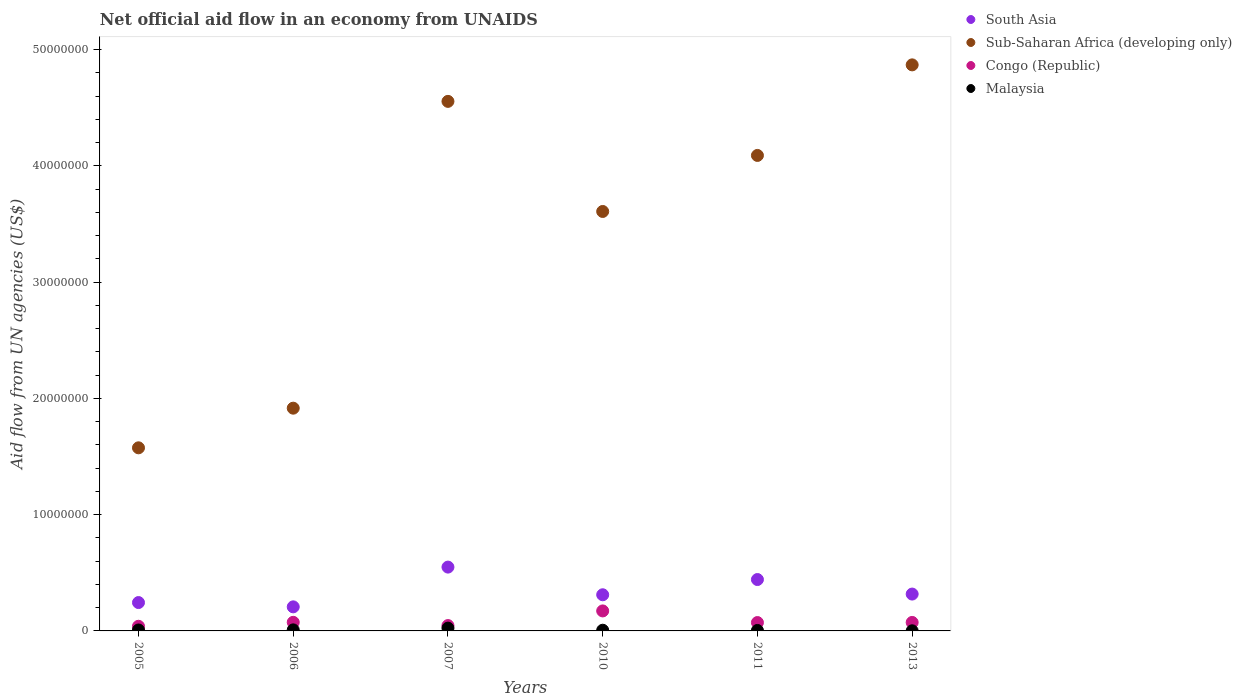How many different coloured dotlines are there?
Keep it short and to the point. 4. Is the number of dotlines equal to the number of legend labels?
Provide a short and direct response. Yes. What is the net official aid flow in Congo (Republic) in 2006?
Offer a very short reply. 7.40e+05. Across all years, what is the maximum net official aid flow in Congo (Republic)?
Give a very brief answer. 1.72e+06. Across all years, what is the minimum net official aid flow in South Asia?
Make the answer very short. 2.07e+06. In which year was the net official aid flow in Congo (Republic) maximum?
Give a very brief answer. 2010. What is the total net official aid flow in Congo (Republic) in the graph?
Offer a very short reply. 4.77e+06. What is the difference between the net official aid flow in South Asia in 2007 and that in 2013?
Your answer should be very brief. 2.32e+06. What is the difference between the net official aid flow in Malaysia in 2011 and the net official aid flow in Congo (Republic) in 2013?
Make the answer very short. -6.90e+05. What is the average net official aid flow in Congo (Republic) per year?
Give a very brief answer. 7.95e+05. In the year 2013, what is the difference between the net official aid flow in Malaysia and net official aid flow in South Asia?
Ensure brevity in your answer.  -3.16e+06. In how many years, is the net official aid flow in Malaysia greater than 2000000 US$?
Your answer should be compact. 0. What is the ratio of the net official aid flow in South Asia in 2006 to that in 2013?
Offer a terse response. 0.65. Is the net official aid flow in Malaysia in 2010 less than that in 2011?
Offer a very short reply. No. What is the difference between the highest and the second highest net official aid flow in Congo (Republic)?
Provide a succinct answer. 9.80e+05. What is the difference between the highest and the lowest net official aid flow in Congo (Republic)?
Your answer should be very brief. 1.32e+06. Is the sum of the net official aid flow in Malaysia in 2005 and 2013 greater than the maximum net official aid flow in Sub-Saharan Africa (developing only) across all years?
Offer a very short reply. No. Is it the case that in every year, the sum of the net official aid flow in Congo (Republic) and net official aid flow in South Asia  is greater than the sum of net official aid flow in Malaysia and net official aid flow in Sub-Saharan Africa (developing only)?
Your answer should be very brief. No. Is it the case that in every year, the sum of the net official aid flow in Malaysia and net official aid flow in South Asia  is greater than the net official aid flow in Sub-Saharan Africa (developing only)?
Your response must be concise. No. Does the net official aid flow in Malaysia monotonically increase over the years?
Give a very brief answer. No. How many years are there in the graph?
Ensure brevity in your answer.  6. What is the difference between two consecutive major ticks on the Y-axis?
Your answer should be very brief. 1.00e+07. Are the values on the major ticks of Y-axis written in scientific E-notation?
Offer a terse response. No. Does the graph contain any zero values?
Offer a very short reply. No. How many legend labels are there?
Your answer should be compact. 4. How are the legend labels stacked?
Offer a terse response. Vertical. What is the title of the graph?
Your answer should be very brief. Net official aid flow in an economy from UNAIDS. What is the label or title of the Y-axis?
Ensure brevity in your answer.  Aid flow from UN agencies (US$). What is the Aid flow from UN agencies (US$) in South Asia in 2005?
Offer a very short reply. 2.44e+06. What is the Aid flow from UN agencies (US$) of Sub-Saharan Africa (developing only) in 2005?
Your answer should be compact. 1.58e+07. What is the Aid flow from UN agencies (US$) of South Asia in 2006?
Your answer should be very brief. 2.07e+06. What is the Aid flow from UN agencies (US$) in Sub-Saharan Africa (developing only) in 2006?
Your response must be concise. 1.92e+07. What is the Aid flow from UN agencies (US$) of Congo (Republic) in 2006?
Ensure brevity in your answer.  7.40e+05. What is the Aid flow from UN agencies (US$) in South Asia in 2007?
Offer a very short reply. 5.49e+06. What is the Aid flow from UN agencies (US$) of Sub-Saharan Africa (developing only) in 2007?
Your answer should be compact. 4.56e+07. What is the Aid flow from UN agencies (US$) of Congo (Republic) in 2007?
Ensure brevity in your answer.  4.60e+05. What is the Aid flow from UN agencies (US$) of South Asia in 2010?
Ensure brevity in your answer.  3.11e+06. What is the Aid flow from UN agencies (US$) in Sub-Saharan Africa (developing only) in 2010?
Provide a succinct answer. 3.61e+07. What is the Aid flow from UN agencies (US$) in Congo (Republic) in 2010?
Offer a terse response. 1.72e+06. What is the Aid flow from UN agencies (US$) in South Asia in 2011?
Keep it short and to the point. 4.42e+06. What is the Aid flow from UN agencies (US$) in Sub-Saharan Africa (developing only) in 2011?
Make the answer very short. 4.09e+07. What is the Aid flow from UN agencies (US$) in Congo (Republic) in 2011?
Provide a short and direct response. 7.20e+05. What is the Aid flow from UN agencies (US$) of Malaysia in 2011?
Your answer should be very brief. 4.00e+04. What is the Aid flow from UN agencies (US$) of South Asia in 2013?
Your answer should be compact. 3.17e+06. What is the Aid flow from UN agencies (US$) of Sub-Saharan Africa (developing only) in 2013?
Your answer should be very brief. 4.87e+07. What is the Aid flow from UN agencies (US$) of Congo (Republic) in 2013?
Provide a short and direct response. 7.30e+05. Across all years, what is the maximum Aid flow from UN agencies (US$) in South Asia?
Keep it short and to the point. 5.49e+06. Across all years, what is the maximum Aid flow from UN agencies (US$) in Sub-Saharan Africa (developing only)?
Your response must be concise. 4.87e+07. Across all years, what is the maximum Aid flow from UN agencies (US$) of Congo (Republic)?
Make the answer very short. 1.72e+06. Across all years, what is the minimum Aid flow from UN agencies (US$) in South Asia?
Your answer should be very brief. 2.07e+06. Across all years, what is the minimum Aid flow from UN agencies (US$) in Sub-Saharan Africa (developing only)?
Keep it short and to the point. 1.58e+07. Across all years, what is the minimum Aid flow from UN agencies (US$) of Congo (Republic)?
Make the answer very short. 4.00e+05. Across all years, what is the minimum Aid flow from UN agencies (US$) of Malaysia?
Give a very brief answer. 10000. What is the total Aid flow from UN agencies (US$) of South Asia in the graph?
Offer a terse response. 2.07e+07. What is the total Aid flow from UN agencies (US$) in Sub-Saharan Africa (developing only) in the graph?
Keep it short and to the point. 2.06e+08. What is the total Aid flow from UN agencies (US$) of Congo (Republic) in the graph?
Give a very brief answer. 4.77e+06. What is the total Aid flow from UN agencies (US$) in Malaysia in the graph?
Make the answer very short. 5.20e+05. What is the difference between the Aid flow from UN agencies (US$) of South Asia in 2005 and that in 2006?
Make the answer very short. 3.70e+05. What is the difference between the Aid flow from UN agencies (US$) of Sub-Saharan Africa (developing only) in 2005 and that in 2006?
Provide a short and direct response. -3.41e+06. What is the difference between the Aid flow from UN agencies (US$) in Malaysia in 2005 and that in 2006?
Offer a terse response. -10000. What is the difference between the Aid flow from UN agencies (US$) of South Asia in 2005 and that in 2007?
Offer a terse response. -3.05e+06. What is the difference between the Aid flow from UN agencies (US$) in Sub-Saharan Africa (developing only) in 2005 and that in 2007?
Offer a very short reply. -2.98e+07. What is the difference between the Aid flow from UN agencies (US$) in South Asia in 2005 and that in 2010?
Keep it short and to the point. -6.70e+05. What is the difference between the Aid flow from UN agencies (US$) of Sub-Saharan Africa (developing only) in 2005 and that in 2010?
Give a very brief answer. -2.03e+07. What is the difference between the Aid flow from UN agencies (US$) in Congo (Republic) in 2005 and that in 2010?
Make the answer very short. -1.32e+06. What is the difference between the Aid flow from UN agencies (US$) in South Asia in 2005 and that in 2011?
Ensure brevity in your answer.  -1.98e+06. What is the difference between the Aid flow from UN agencies (US$) of Sub-Saharan Africa (developing only) in 2005 and that in 2011?
Provide a short and direct response. -2.52e+07. What is the difference between the Aid flow from UN agencies (US$) in Congo (Republic) in 2005 and that in 2011?
Provide a succinct answer. -3.20e+05. What is the difference between the Aid flow from UN agencies (US$) in South Asia in 2005 and that in 2013?
Make the answer very short. -7.30e+05. What is the difference between the Aid flow from UN agencies (US$) in Sub-Saharan Africa (developing only) in 2005 and that in 2013?
Your answer should be compact. -3.29e+07. What is the difference between the Aid flow from UN agencies (US$) in Congo (Republic) in 2005 and that in 2013?
Make the answer very short. -3.30e+05. What is the difference between the Aid flow from UN agencies (US$) of Malaysia in 2005 and that in 2013?
Keep it short and to the point. 7.00e+04. What is the difference between the Aid flow from UN agencies (US$) of South Asia in 2006 and that in 2007?
Provide a short and direct response. -3.42e+06. What is the difference between the Aid flow from UN agencies (US$) in Sub-Saharan Africa (developing only) in 2006 and that in 2007?
Offer a terse response. -2.64e+07. What is the difference between the Aid flow from UN agencies (US$) of Malaysia in 2006 and that in 2007?
Make the answer very short. -1.50e+05. What is the difference between the Aid flow from UN agencies (US$) of South Asia in 2006 and that in 2010?
Make the answer very short. -1.04e+06. What is the difference between the Aid flow from UN agencies (US$) of Sub-Saharan Africa (developing only) in 2006 and that in 2010?
Ensure brevity in your answer.  -1.69e+07. What is the difference between the Aid flow from UN agencies (US$) of Congo (Republic) in 2006 and that in 2010?
Ensure brevity in your answer.  -9.80e+05. What is the difference between the Aid flow from UN agencies (US$) in South Asia in 2006 and that in 2011?
Make the answer very short. -2.35e+06. What is the difference between the Aid flow from UN agencies (US$) in Sub-Saharan Africa (developing only) in 2006 and that in 2011?
Your response must be concise. -2.17e+07. What is the difference between the Aid flow from UN agencies (US$) of South Asia in 2006 and that in 2013?
Give a very brief answer. -1.10e+06. What is the difference between the Aid flow from UN agencies (US$) of Sub-Saharan Africa (developing only) in 2006 and that in 2013?
Offer a very short reply. -2.95e+07. What is the difference between the Aid flow from UN agencies (US$) in Congo (Republic) in 2006 and that in 2013?
Keep it short and to the point. 10000. What is the difference between the Aid flow from UN agencies (US$) of South Asia in 2007 and that in 2010?
Keep it short and to the point. 2.38e+06. What is the difference between the Aid flow from UN agencies (US$) of Sub-Saharan Africa (developing only) in 2007 and that in 2010?
Keep it short and to the point. 9.47e+06. What is the difference between the Aid flow from UN agencies (US$) of Congo (Republic) in 2007 and that in 2010?
Your answer should be very brief. -1.26e+06. What is the difference between the Aid flow from UN agencies (US$) of South Asia in 2007 and that in 2011?
Offer a very short reply. 1.07e+06. What is the difference between the Aid flow from UN agencies (US$) in Sub-Saharan Africa (developing only) in 2007 and that in 2011?
Make the answer very short. 4.65e+06. What is the difference between the Aid flow from UN agencies (US$) of Congo (Republic) in 2007 and that in 2011?
Provide a succinct answer. -2.60e+05. What is the difference between the Aid flow from UN agencies (US$) of Malaysia in 2007 and that in 2011?
Ensure brevity in your answer.  2.00e+05. What is the difference between the Aid flow from UN agencies (US$) in South Asia in 2007 and that in 2013?
Keep it short and to the point. 2.32e+06. What is the difference between the Aid flow from UN agencies (US$) of Sub-Saharan Africa (developing only) in 2007 and that in 2013?
Ensure brevity in your answer.  -3.14e+06. What is the difference between the Aid flow from UN agencies (US$) in South Asia in 2010 and that in 2011?
Your response must be concise. -1.31e+06. What is the difference between the Aid flow from UN agencies (US$) of Sub-Saharan Africa (developing only) in 2010 and that in 2011?
Give a very brief answer. -4.82e+06. What is the difference between the Aid flow from UN agencies (US$) of Malaysia in 2010 and that in 2011?
Your response must be concise. 2.00e+04. What is the difference between the Aid flow from UN agencies (US$) in Sub-Saharan Africa (developing only) in 2010 and that in 2013?
Your answer should be very brief. -1.26e+07. What is the difference between the Aid flow from UN agencies (US$) of Congo (Republic) in 2010 and that in 2013?
Provide a succinct answer. 9.90e+05. What is the difference between the Aid flow from UN agencies (US$) of South Asia in 2011 and that in 2013?
Your answer should be very brief. 1.25e+06. What is the difference between the Aid flow from UN agencies (US$) of Sub-Saharan Africa (developing only) in 2011 and that in 2013?
Ensure brevity in your answer.  -7.79e+06. What is the difference between the Aid flow from UN agencies (US$) in South Asia in 2005 and the Aid flow from UN agencies (US$) in Sub-Saharan Africa (developing only) in 2006?
Make the answer very short. -1.67e+07. What is the difference between the Aid flow from UN agencies (US$) in South Asia in 2005 and the Aid flow from UN agencies (US$) in Congo (Republic) in 2006?
Provide a succinct answer. 1.70e+06. What is the difference between the Aid flow from UN agencies (US$) of South Asia in 2005 and the Aid flow from UN agencies (US$) of Malaysia in 2006?
Keep it short and to the point. 2.35e+06. What is the difference between the Aid flow from UN agencies (US$) in Sub-Saharan Africa (developing only) in 2005 and the Aid flow from UN agencies (US$) in Congo (Republic) in 2006?
Ensure brevity in your answer.  1.50e+07. What is the difference between the Aid flow from UN agencies (US$) of Sub-Saharan Africa (developing only) in 2005 and the Aid flow from UN agencies (US$) of Malaysia in 2006?
Offer a very short reply. 1.57e+07. What is the difference between the Aid flow from UN agencies (US$) in Congo (Republic) in 2005 and the Aid flow from UN agencies (US$) in Malaysia in 2006?
Provide a succinct answer. 3.10e+05. What is the difference between the Aid flow from UN agencies (US$) in South Asia in 2005 and the Aid flow from UN agencies (US$) in Sub-Saharan Africa (developing only) in 2007?
Your answer should be compact. -4.31e+07. What is the difference between the Aid flow from UN agencies (US$) in South Asia in 2005 and the Aid flow from UN agencies (US$) in Congo (Republic) in 2007?
Your response must be concise. 1.98e+06. What is the difference between the Aid flow from UN agencies (US$) of South Asia in 2005 and the Aid flow from UN agencies (US$) of Malaysia in 2007?
Offer a very short reply. 2.20e+06. What is the difference between the Aid flow from UN agencies (US$) in Sub-Saharan Africa (developing only) in 2005 and the Aid flow from UN agencies (US$) in Congo (Republic) in 2007?
Your answer should be very brief. 1.53e+07. What is the difference between the Aid flow from UN agencies (US$) in Sub-Saharan Africa (developing only) in 2005 and the Aid flow from UN agencies (US$) in Malaysia in 2007?
Offer a very short reply. 1.55e+07. What is the difference between the Aid flow from UN agencies (US$) in Congo (Republic) in 2005 and the Aid flow from UN agencies (US$) in Malaysia in 2007?
Provide a short and direct response. 1.60e+05. What is the difference between the Aid flow from UN agencies (US$) of South Asia in 2005 and the Aid flow from UN agencies (US$) of Sub-Saharan Africa (developing only) in 2010?
Offer a very short reply. -3.36e+07. What is the difference between the Aid flow from UN agencies (US$) of South Asia in 2005 and the Aid flow from UN agencies (US$) of Congo (Republic) in 2010?
Keep it short and to the point. 7.20e+05. What is the difference between the Aid flow from UN agencies (US$) in South Asia in 2005 and the Aid flow from UN agencies (US$) in Malaysia in 2010?
Give a very brief answer. 2.38e+06. What is the difference between the Aid flow from UN agencies (US$) of Sub-Saharan Africa (developing only) in 2005 and the Aid flow from UN agencies (US$) of Congo (Republic) in 2010?
Keep it short and to the point. 1.40e+07. What is the difference between the Aid flow from UN agencies (US$) of Sub-Saharan Africa (developing only) in 2005 and the Aid flow from UN agencies (US$) of Malaysia in 2010?
Keep it short and to the point. 1.57e+07. What is the difference between the Aid flow from UN agencies (US$) in South Asia in 2005 and the Aid flow from UN agencies (US$) in Sub-Saharan Africa (developing only) in 2011?
Ensure brevity in your answer.  -3.85e+07. What is the difference between the Aid flow from UN agencies (US$) of South Asia in 2005 and the Aid flow from UN agencies (US$) of Congo (Republic) in 2011?
Provide a short and direct response. 1.72e+06. What is the difference between the Aid flow from UN agencies (US$) of South Asia in 2005 and the Aid flow from UN agencies (US$) of Malaysia in 2011?
Your answer should be compact. 2.40e+06. What is the difference between the Aid flow from UN agencies (US$) of Sub-Saharan Africa (developing only) in 2005 and the Aid flow from UN agencies (US$) of Congo (Republic) in 2011?
Make the answer very short. 1.50e+07. What is the difference between the Aid flow from UN agencies (US$) in Sub-Saharan Africa (developing only) in 2005 and the Aid flow from UN agencies (US$) in Malaysia in 2011?
Your answer should be compact. 1.57e+07. What is the difference between the Aid flow from UN agencies (US$) in Congo (Republic) in 2005 and the Aid flow from UN agencies (US$) in Malaysia in 2011?
Your response must be concise. 3.60e+05. What is the difference between the Aid flow from UN agencies (US$) of South Asia in 2005 and the Aid flow from UN agencies (US$) of Sub-Saharan Africa (developing only) in 2013?
Provide a succinct answer. -4.62e+07. What is the difference between the Aid flow from UN agencies (US$) of South Asia in 2005 and the Aid flow from UN agencies (US$) of Congo (Republic) in 2013?
Ensure brevity in your answer.  1.71e+06. What is the difference between the Aid flow from UN agencies (US$) of South Asia in 2005 and the Aid flow from UN agencies (US$) of Malaysia in 2013?
Offer a very short reply. 2.43e+06. What is the difference between the Aid flow from UN agencies (US$) in Sub-Saharan Africa (developing only) in 2005 and the Aid flow from UN agencies (US$) in Congo (Republic) in 2013?
Provide a short and direct response. 1.50e+07. What is the difference between the Aid flow from UN agencies (US$) of Sub-Saharan Africa (developing only) in 2005 and the Aid flow from UN agencies (US$) of Malaysia in 2013?
Offer a very short reply. 1.57e+07. What is the difference between the Aid flow from UN agencies (US$) in Congo (Republic) in 2005 and the Aid flow from UN agencies (US$) in Malaysia in 2013?
Offer a very short reply. 3.90e+05. What is the difference between the Aid flow from UN agencies (US$) in South Asia in 2006 and the Aid flow from UN agencies (US$) in Sub-Saharan Africa (developing only) in 2007?
Make the answer very short. -4.35e+07. What is the difference between the Aid flow from UN agencies (US$) of South Asia in 2006 and the Aid flow from UN agencies (US$) of Congo (Republic) in 2007?
Give a very brief answer. 1.61e+06. What is the difference between the Aid flow from UN agencies (US$) of South Asia in 2006 and the Aid flow from UN agencies (US$) of Malaysia in 2007?
Give a very brief answer. 1.83e+06. What is the difference between the Aid flow from UN agencies (US$) in Sub-Saharan Africa (developing only) in 2006 and the Aid flow from UN agencies (US$) in Congo (Republic) in 2007?
Provide a succinct answer. 1.87e+07. What is the difference between the Aid flow from UN agencies (US$) in Sub-Saharan Africa (developing only) in 2006 and the Aid flow from UN agencies (US$) in Malaysia in 2007?
Offer a very short reply. 1.89e+07. What is the difference between the Aid flow from UN agencies (US$) in South Asia in 2006 and the Aid flow from UN agencies (US$) in Sub-Saharan Africa (developing only) in 2010?
Provide a short and direct response. -3.40e+07. What is the difference between the Aid flow from UN agencies (US$) of South Asia in 2006 and the Aid flow from UN agencies (US$) of Malaysia in 2010?
Offer a very short reply. 2.01e+06. What is the difference between the Aid flow from UN agencies (US$) of Sub-Saharan Africa (developing only) in 2006 and the Aid flow from UN agencies (US$) of Congo (Republic) in 2010?
Your answer should be very brief. 1.74e+07. What is the difference between the Aid flow from UN agencies (US$) of Sub-Saharan Africa (developing only) in 2006 and the Aid flow from UN agencies (US$) of Malaysia in 2010?
Give a very brief answer. 1.91e+07. What is the difference between the Aid flow from UN agencies (US$) of Congo (Republic) in 2006 and the Aid flow from UN agencies (US$) of Malaysia in 2010?
Your answer should be compact. 6.80e+05. What is the difference between the Aid flow from UN agencies (US$) of South Asia in 2006 and the Aid flow from UN agencies (US$) of Sub-Saharan Africa (developing only) in 2011?
Provide a short and direct response. -3.88e+07. What is the difference between the Aid flow from UN agencies (US$) of South Asia in 2006 and the Aid flow from UN agencies (US$) of Congo (Republic) in 2011?
Your answer should be very brief. 1.35e+06. What is the difference between the Aid flow from UN agencies (US$) of South Asia in 2006 and the Aid flow from UN agencies (US$) of Malaysia in 2011?
Provide a short and direct response. 2.03e+06. What is the difference between the Aid flow from UN agencies (US$) of Sub-Saharan Africa (developing only) in 2006 and the Aid flow from UN agencies (US$) of Congo (Republic) in 2011?
Provide a short and direct response. 1.84e+07. What is the difference between the Aid flow from UN agencies (US$) in Sub-Saharan Africa (developing only) in 2006 and the Aid flow from UN agencies (US$) in Malaysia in 2011?
Offer a very short reply. 1.91e+07. What is the difference between the Aid flow from UN agencies (US$) of South Asia in 2006 and the Aid flow from UN agencies (US$) of Sub-Saharan Africa (developing only) in 2013?
Keep it short and to the point. -4.66e+07. What is the difference between the Aid flow from UN agencies (US$) in South Asia in 2006 and the Aid flow from UN agencies (US$) in Congo (Republic) in 2013?
Your answer should be very brief. 1.34e+06. What is the difference between the Aid flow from UN agencies (US$) in South Asia in 2006 and the Aid flow from UN agencies (US$) in Malaysia in 2013?
Make the answer very short. 2.06e+06. What is the difference between the Aid flow from UN agencies (US$) in Sub-Saharan Africa (developing only) in 2006 and the Aid flow from UN agencies (US$) in Congo (Republic) in 2013?
Your response must be concise. 1.84e+07. What is the difference between the Aid flow from UN agencies (US$) in Sub-Saharan Africa (developing only) in 2006 and the Aid flow from UN agencies (US$) in Malaysia in 2013?
Keep it short and to the point. 1.92e+07. What is the difference between the Aid flow from UN agencies (US$) of Congo (Republic) in 2006 and the Aid flow from UN agencies (US$) of Malaysia in 2013?
Offer a terse response. 7.30e+05. What is the difference between the Aid flow from UN agencies (US$) of South Asia in 2007 and the Aid flow from UN agencies (US$) of Sub-Saharan Africa (developing only) in 2010?
Ensure brevity in your answer.  -3.06e+07. What is the difference between the Aid flow from UN agencies (US$) of South Asia in 2007 and the Aid flow from UN agencies (US$) of Congo (Republic) in 2010?
Provide a succinct answer. 3.77e+06. What is the difference between the Aid flow from UN agencies (US$) of South Asia in 2007 and the Aid flow from UN agencies (US$) of Malaysia in 2010?
Provide a succinct answer. 5.43e+06. What is the difference between the Aid flow from UN agencies (US$) in Sub-Saharan Africa (developing only) in 2007 and the Aid flow from UN agencies (US$) in Congo (Republic) in 2010?
Your answer should be compact. 4.38e+07. What is the difference between the Aid flow from UN agencies (US$) in Sub-Saharan Africa (developing only) in 2007 and the Aid flow from UN agencies (US$) in Malaysia in 2010?
Offer a terse response. 4.55e+07. What is the difference between the Aid flow from UN agencies (US$) of Congo (Republic) in 2007 and the Aid flow from UN agencies (US$) of Malaysia in 2010?
Provide a succinct answer. 4.00e+05. What is the difference between the Aid flow from UN agencies (US$) of South Asia in 2007 and the Aid flow from UN agencies (US$) of Sub-Saharan Africa (developing only) in 2011?
Make the answer very short. -3.54e+07. What is the difference between the Aid flow from UN agencies (US$) of South Asia in 2007 and the Aid flow from UN agencies (US$) of Congo (Republic) in 2011?
Keep it short and to the point. 4.77e+06. What is the difference between the Aid flow from UN agencies (US$) of South Asia in 2007 and the Aid flow from UN agencies (US$) of Malaysia in 2011?
Offer a terse response. 5.45e+06. What is the difference between the Aid flow from UN agencies (US$) of Sub-Saharan Africa (developing only) in 2007 and the Aid flow from UN agencies (US$) of Congo (Republic) in 2011?
Ensure brevity in your answer.  4.48e+07. What is the difference between the Aid flow from UN agencies (US$) of Sub-Saharan Africa (developing only) in 2007 and the Aid flow from UN agencies (US$) of Malaysia in 2011?
Keep it short and to the point. 4.55e+07. What is the difference between the Aid flow from UN agencies (US$) in Congo (Republic) in 2007 and the Aid flow from UN agencies (US$) in Malaysia in 2011?
Provide a short and direct response. 4.20e+05. What is the difference between the Aid flow from UN agencies (US$) in South Asia in 2007 and the Aid flow from UN agencies (US$) in Sub-Saharan Africa (developing only) in 2013?
Offer a terse response. -4.32e+07. What is the difference between the Aid flow from UN agencies (US$) in South Asia in 2007 and the Aid flow from UN agencies (US$) in Congo (Republic) in 2013?
Offer a very short reply. 4.76e+06. What is the difference between the Aid flow from UN agencies (US$) of South Asia in 2007 and the Aid flow from UN agencies (US$) of Malaysia in 2013?
Make the answer very short. 5.48e+06. What is the difference between the Aid flow from UN agencies (US$) in Sub-Saharan Africa (developing only) in 2007 and the Aid flow from UN agencies (US$) in Congo (Republic) in 2013?
Make the answer very short. 4.48e+07. What is the difference between the Aid flow from UN agencies (US$) of Sub-Saharan Africa (developing only) in 2007 and the Aid flow from UN agencies (US$) of Malaysia in 2013?
Keep it short and to the point. 4.55e+07. What is the difference between the Aid flow from UN agencies (US$) in Congo (Republic) in 2007 and the Aid flow from UN agencies (US$) in Malaysia in 2013?
Ensure brevity in your answer.  4.50e+05. What is the difference between the Aid flow from UN agencies (US$) in South Asia in 2010 and the Aid flow from UN agencies (US$) in Sub-Saharan Africa (developing only) in 2011?
Offer a very short reply. -3.78e+07. What is the difference between the Aid flow from UN agencies (US$) in South Asia in 2010 and the Aid flow from UN agencies (US$) in Congo (Republic) in 2011?
Ensure brevity in your answer.  2.39e+06. What is the difference between the Aid flow from UN agencies (US$) of South Asia in 2010 and the Aid flow from UN agencies (US$) of Malaysia in 2011?
Your response must be concise. 3.07e+06. What is the difference between the Aid flow from UN agencies (US$) of Sub-Saharan Africa (developing only) in 2010 and the Aid flow from UN agencies (US$) of Congo (Republic) in 2011?
Give a very brief answer. 3.54e+07. What is the difference between the Aid flow from UN agencies (US$) of Sub-Saharan Africa (developing only) in 2010 and the Aid flow from UN agencies (US$) of Malaysia in 2011?
Give a very brief answer. 3.60e+07. What is the difference between the Aid flow from UN agencies (US$) in Congo (Republic) in 2010 and the Aid flow from UN agencies (US$) in Malaysia in 2011?
Your answer should be compact. 1.68e+06. What is the difference between the Aid flow from UN agencies (US$) of South Asia in 2010 and the Aid flow from UN agencies (US$) of Sub-Saharan Africa (developing only) in 2013?
Make the answer very short. -4.56e+07. What is the difference between the Aid flow from UN agencies (US$) of South Asia in 2010 and the Aid flow from UN agencies (US$) of Congo (Republic) in 2013?
Ensure brevity in your answer.  2.38e+06. What is the difference between the Aid flow from UN agencies (US$) in South Asia in 2010 and the Aid flow from UN agencies (US$) in Malaysia in 2013?
Provide a short and direct response. 3.10e+06. What is the difference between the Aid flow from UN agencies (US$) in Sub-Saharan Africa (developing only) in 2010 and the Aid flow from UN agencies (US$) in Congo (Republic) in 2013?
Keep it short and to the point. 3.54e+07. What is the difference between the Aid flow from UN agencies (US$) of Sub-Saharan Africa (developing only) in 2010 and the Aid flow from UN agencies (US$) of Malaysia in 2013?
Keep it short and to the point. 3.61e+07. What is the difference between the Aid flow from UN agencies (US$) in Congo (Republic) in 2010 and the Aid flow from UN agencies (US$) in Malaysia in 2013?
Your answer should be very brief. 1.71e+06. What is the difference between the Aid flow from UN agencies (US$) of South Asia in 2011 and the Aid flow from UN agencies (US$) of Sub-Saharan Africa (developing only) in 2013?
Your answer should be compact. -4.43e+07. What is the difference between the Aid flow from UN agencies (US$) of South Asia in 2011 and the Aid flow from UN agencies (US$) of Congo (Republic) in 2013?
Make the answer very short. 3.69e+06. What is the difference between the Aid flow from UN agencies (US$) of South Asia in 2011 and the Aid flow from UN agencies (US$) of Malaysia in 2013?
Your answer should be very brief. 4.41e+06. What is the difference between the Aid flow from UN agencies (US$) in Sub-Saharan Africa (developing only) in 2011 and the Aid flow from UN agencies (US$) in Congo (Republic) in 2013?
Ensure brevity in your answer.  4.02e+07. What is the difference between the Aid flow from UN agencies (US$) of Sub-Saharan Africa (developing only) in 2011 and the Aid flow from UN agencies (US$) of Malaysia in 2013?
Provide a succinct answer. 4.09e+07. What is the difference between the Aid flow from UN agencies (US$) in Congo (Republic) in 2011 and the Aid flow from UN agencies (US$) in Malaysia in 2013?
Provide a succinct answer. 7.10e+05. What is the average Aid flow from UN agencies (US$) in South Asia per year?
Offer a very short reply. 3.45e+06. What is the average Aid flow from UN agencies (US$) of Sub-Saharan Africa (developing only) per year?
Your response must be concise. 3.44e+07. What is the average Aid flow from UN agencies (US$) in Congo (Republic) per year?
Your answer should be very brief. 7.95e+05. What is the average Aid flow from UN agencies (US$) of Malaysia per year?
Your answer should be very brief. 8.67e+04. In the year 2005, what is the difference between the Aid flow from UN agencies (US$) in South Asia and Aid flow from UN agencies (US$) in Sub-Saharan Africa (developing only)?
Give a very brief answer. -1.33e+07. In the year 2005, what is the difference between the Aid flow from UN agencies (US$) in South Asia and Aid flow from UN agencies (US$) in Congo (Republic)?
Your answer should be compact. 2.04e+06. In the year 2005, what is the difference between the Aid flow from UN agencies (US$) of South Asia and Aid flow from UN agencies (US$) of Malaysia?
Give a very brief answer. 2.36e+06. In the year 2005, what is the difference between the Aid flow from UN agencies (US$) in Sub-Saharan Africa (developing only) and Aid flow from UN agencies (US$) in Congo (Republic)?
Ensure brevity in your answer.  1.54e+07. In the year 2005, what is the difference between the Aid flow from UN agencies (US$) of Sub-Saharan Africa (developing only) and Aid flow from UN agencies (US$) of Malaysia?
Your answer should be very brief. 1.57e+07. In the year 2005, what is the difference between the Aid flow from UN agencies (US$) of Congo (Republic) and Aid flow from UN agencies (US$) of Malaysia?
Your response must be concise. 3.20e+05. In the year 2006, what is the difference between the Aid flow from UN agencies (US$) in South Asia and Aid flow from UN agencies (US$) in Sub-Saharan Africa (developing only)?
Give a very brief answer. -1.71e+07. In the year 2006, what is the difference between the Aid flow from UN agencies (US$) of South Asia and Aid flow from UN agencies (US$) of Congo (Republic)?
Offer a very short reply. 1.33e+06. In the year 2006, what is the difference between the Aid flow from UN agencies (US$) of South Asia and Aid flow from UN agencies (US$) of Malaysia?
Provide a short and direct response. 1.98e+06. In the year 2006, what is the difference between the Aid flow from UN agencies (US$) in Sub-Saharan Africa (developing only) and Aid flow from UN agencies (US$) in Congo (Republic)?
Your response must be concise. 1.84e+07. In the year 2006, what is the difference between the Aid flow from UN agencies (US$) in Sub-Saharan Africa (developing only) and Aid flow from UN agencies (US$) in Malaysia?
Your response must be concise. 1.91e+07. In the year 2006, what is the difference between the Aid flow from UN agencies (US$) in Congo (Republic) and Aid flow from UN agencies (US$) in Malaysia?
Provide a short and direct response. 6.50e+05. In the year 2007, what is the difference between the Aid flow from UN agencies (US$) of South Asia and Aid flow from UN agencies (US$) of Sub-Saharan Africa (developing only)?
Your answer should be compact. -4.01e+07. In the year 2007, what is the difference between the Aid flow from UN agencies (US$) in South Asia and Aid flow from UN agencies (US$) in Congo (Republic)?
Your answer should be very brief. 5.03e+06. In the year 2007, what is the difference between the Aid flow from UN agencies (US$) in South Asia and Aid flow from UN agencies (US$) in Malaysia?
Your response must be concise. 5.25e+06. In the year 2007, what is the difference between the Aid flow from UN agencies (US$) of Sub-Saharan Africa (developing only) and Aid flow from UN agencies (US$) of Congo (Republic)?
Give a very brief answer. 4.51e+07. In the year 2007, what is the difference between the Aid flow from UN agencies (US$) in Sub-Saharan Africa (developing only) and Aid flow from UN agencies (US$) in Malaysia?
Your response must be concise. 4.53e+07. In the year 2007, what is the difference between the Aid flow from UN agencies (US$) of Congo (Republic) and Aid flow from UN agencies (US$) of Malaysia?
Give a very brief answer. 2.20e+05. In the year 2010, what is the difference between the Aid flow from UN agencies (US$) in South Asia and Aid flow from UN agencies (US$) in Sub-Saharan Africa (developing only)?
Your answer should be compact. -3.30e+07. In the year 2010, what is the difference between the Aid flow from UN agencies (US$) in South Asia and Aid flow from UN agencies (US$) in Congo (Republic)?
Your answer should be very brief. 1.39e+06. In the year 2010, what is the difference between the Aid flow from UN agencies (US$) in South Asia and Aid flow from UN agencies (US$) in Malaysia?
Your answer should be compact. 3.05e+06. In the year 2010, what is the difference between the Aid flow from UN agencies (US$) in Sub-Saharan Africa (developing only) and Aid flow from UN agencies (US$) in Congo (Republic)?
Your response must be concise. 3.44e+07. In the year 2010, what is the difference between the Aid flow from UN agencies (US$) in Sub-Saharan Africa (developing only) and Aid flow from UN agencies (US$) in Malaysia?
Keep it short and to the point. 3.60e+07. In the year 2010, what is the difference between the Aid flow from UN agencies (US$) of Congo (Republic) and Aid flow from UN agencies (US$) of Malaysia?
Your answer should be compact. 1.66e+06. In the year 2011, what is the difference between the Aid flow from UN agencies (US$) in South Asia and Aid flow from UN agencies (US$) in Sub-Saharan Africa (developing only)?
Give a very brief answer. -3.65e+07. In the year 2011, what is the difference between the Aid flow from UN agencies (US$) of South Asia and Aid flow from UN agencies (US$) of Congo (Republic)?
Provide a succinct answer. 3.70e+06. In the year 2011, what is the difference between the Aid flow from UN agencies (US$) of South Asia and Aid flow from UN agencies (US$) of Malaysia?
Your answer should be very brief. 4.38e+06. In the year 2011, what is the difference between the Aid flow from UN agencies (US$) of Sub-Saharan Africa (developing only) and Aid flow from UN agencies (US$) of Congo (Republic)?
Offer a terse response. 4.02e+07. In the year 2011, what is the difference between the Aid flow from UN agencies (US$) in Sub-Saharan Africa (developing only) and Aid flow from UN agencies (US$) in Malaysia?
Ensure brevity in your answer.  4.09e+07. In the year 2011, what is the difference between the Aid flow from UN agencies (US$) in Congo (Republic) and Aid flow from UN agencies (US$) in Malaysia?
Provide a short and direct response. 6.80e+05. In the year 2013, what is the difference between the Aid flow from UN agencies (US$) of South Asia and Aid flow from UN agencies (US$) of Sub-Saharan Africa (developing only)?
Make the answer very short. -4.55e+07. In the year 2013, what is the difference between the Aid flow from UN agencies (US$) of South Asia and Aid flow from UN agencies (US$) of Congo (Republic)?
Ensure brevity in your answer.  2.44e+06. In the year 2013, what is the difference between the Aid flow from UN agencies (US$) of South Asia and Aid flow from UN agencies (US$) of Malaysia?
Make the answer very short. 3.16e+06. In the year 2013, what is the difference between the Aid flow from UN agencies (US$) of Sub-Saharan Africa (developing only) and Aid flow from UN agencies (US$) of Congo (Republic)?
Make the answer very short. 4.80e+07. In the year 2013, what is the difference between the Aid flow from UN agencies (US$) of Sub-Saharan Africa (developing only) and Aid flow from UN agencies (US$) of Malaysia?
Keep it short and to the point. 4.87e+07. In the year 2013, what is the difference between the Aid flow from UN agencies (US$) of Congo (Republic) and Aid flow from UN agencies (US$) of Malaysia?
Your answer should be very brief. 7.20e+05. What is the ratio of the Aid flow from UN agencies (US$) in South Asia in 2005 to that in 2006?
Offer a very short reply. 1.18. What is the ratio of the Aid flow from UN agencies (US$) in Sub-Saharan Africa (developing only) in 2005 to that in 2006?
Your answer should be very brief. 0.82. What is the ratio of the Aid flow from UN agencies (US$) of Congo (Republic) in 2005 to that in 2006?
Make the answer very short. 0.54. What is the ratio of the Aid flow from UN agencies (US$) of Malaysia in 2005 to that in 2006?
Keep it short and to the point. 0.89. What is the ratio of the Aid flow from UN agencies (US$) of South Asia in 2005 to that in 2007?
Offer a very short reply. 0.44. What is the ratio of the Aid flow from UN agencies (US$) of Sub-Saharan Africa (developing only) in 2005 to that in 2007?
Your answer should be compact. 0.35. What is the ratio of the Aid flow from UN agencies (US$) of Congo (Republic) in 2005 to that in 2007?
Keep it short and to the point. 0.87. What is the ratio of the Aid flow from UN agencies (US$) in Malaysia in 2005 to that in 2007?
Offer a terse response. 0.33. What is the ratio of the Aid flow from UN agencies (US$) of South Asia in 2005 to that in 2010?
Your response must be concise. 0.78. What is the ratio of the Aid flow from UN agencies (US$) of Sub-Saharan Africa (developing only) in 2005 to that in 2010?
Provide a succinct answer. 0.44. What is the ratio of the Aid flow from UN agencies (US$) of Congo (Republic) in 2005 to that in 2010?
Provide a short and direct response. 0.23. What is the ratio of the Aid flow from UN agencies (US$) in Malaysia in 2005 to that in 2010?
Your response must be concise. 1.33. What is the ratio of the Aid flow from UN agencies (US$) in South Asia in 2005 to that in 2011?
Ensure brevity in your answer.  0.55. What is the ratio of the Aid flow from UN agencies (US$) in Sub-Saharan Africa (developing only) in 2005 to that in 2011?
Offer a very short reply. 0.39. What is the ratio of the Aid flow from UN agencies (US$) of Congo (Republic) in 2005 to that in 2011?
Ensure brevity in your answer.  0.56. What is the ratio of the Aid flow from UN agencies (US$) of Malaysia in 2005 to that in 2011?
Provide a succinct answer. 2. What is the ratio of the Aid flow from UN agencies (US$) of South Asia in 2005 to that in 2013?
Ensure brevity in your answer.  0.77. What is the ratio of the Aid flow from UN agencies (US$) in Sub-Saharan Africa (developing only) in 2005 to that in 2013?
Offer a terse response. 0.32. What is the ratio of the Aid flow from UN agencies (US$) in Congo (Republic) in 2005 to that in 2013?
Make the answer very short. 0.55. What is the ratio of the Aid flow from UN agencies (US$) in South Asia in 2006 to that in 2007?
Ensure brevity in your answer.  0.38. What is the ratio of the Aid flow from UN agencies (US$) of Sub-Saharan Africa (developing only) in 2006 to that in 2007?
Provide a short and direct response. 0.42. What is the ratio of the Aid flow from UN agencies (US$) in Congo (Republic) in 2006 to that in 2007?
Your answer should be compact. 1.61. What is the ratio of the Aid flow from UN agencies (US$) in South Asia in 2006 to that in 2010?
Provide a succinct answer. 0.67. What is the ratio of the Aid flow from UN agencies (US$) of Sub-Saharan Africa (developing only) in 2006 to that in 2010?
Give a very brief answer. 0.53. What is the ratio of the Aid flow from UN agencies (US$) of Congo (Republic) in 2006 to that in 2010?
Give a very brief answer. 0.43. What is the ratio of the Aid flow from UN agencies (US$) in South Asia in 2006 to that in 2011?
Provide a succinct answer. 0.47. What is the ratio of the Aid flow from UN agencies (US$) of Sub-Saharan Africa (developing only) in 2006 to that in 2011?
Provide a short and direct response. 0.47. What is the ratio of the Aid flow from UN agencies (US$) of Congo (Republic) in 2006 to that in 2011?
Give a very brief answer. 1.03. What is the ratio of the Aid flow from UN agencies (US$) of Malaysia in 2006 to that in 2011?
Give a very brief answer. 2.25. What is the ratio of the Aid flow from UN agencies (US$) in South Asia in 2006 to that in 2013?
Provide a succinct answer. 0.65. What is the ratio of the Aid flow from UN agencies (US$) of Sub-Saharan Africa (developing only) in 2006 to that in 2013?
Provide a succinct answer. 0.39. What is the ratio of the Aid flow from UN agencies (US$) of Congo (Republic) in 2006 to that in 2013?
Give a very brief answer. 1.01. What is the ratio of the Aid flow from UN agencies (US$) of South Asia in 2007 to that in 2010?
Offer a terse response. 1.77. What is the ratio of the Aid flow from UN agencies (US$) of Sub-Saharan Africa (developing only) in 2007 to that in 2010?
Provide a short and direct response. 1.26. What is the ratio of the Aid flow from UN agencies (US$) of Congo (Republic) in 2007 to that in 2010?
Your response must be concise. 0.27. What is the ratio of the Aid flow from UN agencies (US$) of Malaysia in 2007 to that in 2010?
Offer a very short reply. 4. What is the ratio of the Aid flow from UN agencies (US$) in South Asia in 2007 to that in 2011?
Make the answer very short. 1.24. What is the ratio of the Aid flow from UN agencies (US$) of Sub-Saharan Africa (developing only) in 2007 to that in 2011?
Provide a succinct answer. 1.11. What is the ratio of the Aid flow from UN agencies (US$) in Congo (Republic) in 2007 to that in 2011?
Your response must be concise. 0.64. What is the ratio of the Aid flow from UN agencies (US$) of South Asia in 2007 to that in 2013?
Your answer should be compact. 1.73. What is the ratio of the Aid flow from UN agencies (US$) of Sub-Saharan Africa (developing only) in 2007 to that in 2013?
Your answer should be very brief. 0.94. What is the ratio of the Aid flow from UN agencies (US$) in Congo (Republic) in 2007 to that in 2013?
Ensure brevity in your answer.  0.63. What is the ratio of the Aid flow from UN agencies (US$) in Malaysia in 2007 to that in 2013?
Your answer should be compact. 24. What is the ratio of the Aid flow from UN agencies (US$) in South Asia in 2010 to that in 2011?
Offer a terse response. 0.7. What is the ratio of the Aid flow from UN agencies (US$) of Sub-Saharan Africa (developing only) in 2010 to that in 2011?
Ensure brevity in your answer.  0.88. What is the ratio of the Aid flow from UN agencies (US$) of Congo (Republic) in 2010 to that in 2011?
Offer a very short reply. 2.39. What is the ratio of the Aid flow from UN agencies (US$) in Malaysia in 2010 to that in 2011?
Provide a succinct answer. 1.5. What is the ratio of the Aid flow from UN agencies (US$) of South Asia in 2010 to that in 2013?
Offer a terse response. 0.98. What is the ratio of the Aid flow from UN agencies (US$) in Sub-Saharan Africa (developing only) in 2010 to that in 2013?
Give a very brief answer. 0.74. What is the ratio of the Aid flow from UN agencies (US$) of Congo (Republic) in 2010 to that in 2013?
Keep it short and to the point. 2.36. What is the ratio of the Aid flow from UN agencies (US$) in Malaysia in 2010 to that in 2013?
Keep it short and to the point. 6. What is the ratio of the Aid flow from UN agencies (US$) of South Asia in 2011 to that in 2013?
Ensure brevity in your answer.  1.39. What is the ratio of the Aid flow from UN agencies (US$) of Sub-Saharan Africa (developing only) in 2011 to that in 2013?
Ensure brevity in your answer.  0.84. What is the ratio of the Aid flow from UN agencies (US$) in Congo (Republic) in 2011 to that in 2013?
Offer a terse response. 0.99. What is the difference between the highest and the second highest Aid flow from UN agencies (US$) of South Asia?
Offer a very short reply. 1.07e+06. What is the difference between the highest and the second highest Aid flow from UN agencies (US$) in Sub-Saharan Africa (developing only)?
Make the answer very short. 3.14e+06. What is the difference between the highest and the second highest Aid flow from UN agencies (US$) in Congo (Republic)?
Offer a very short reply. 9.80e+05. What is the difference between the highest and the lowest Aid flow from UN agencies (US$) in South Asia?
Provide a short and direct response. 3.42e+06. What is the difference between the highest and the lowest Aid flow from UN agencies (US$) in Sub-Saharan Africa (developing only)?
Give a very brief answer. 3.29e+07. What is the difference between the highest and the lowest Aid flow from UN agencies (US$) in Congo (Republic)?
Make the answer very short. 1.32e+06. What is the difference between the highest and the lowest Aid flow from UN agencies (US$) of Malaysia?
Make the answer very short. 2.30e+05. 